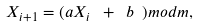Convert formula to latex. <formula><loc_0><loc_0><loc_500><loc_500>X _ { i + 1 } = ( a X _ { i } \ + \ b \ ) m o d m ,</formula> 